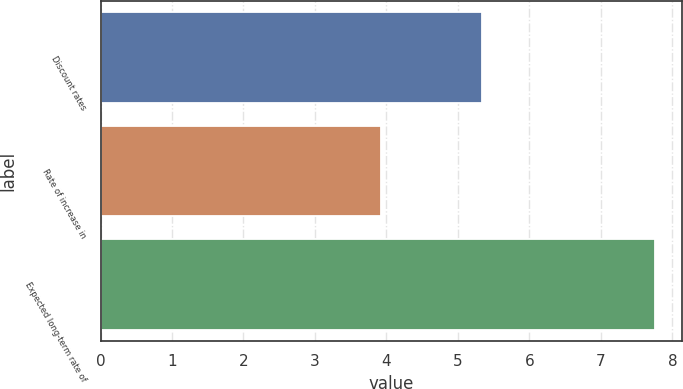<chart> <loc_0><loc_0><loc_500><loc_500><bar_chart><fcel>Discount rates<fcel>Rate of increase in<fcel>Expected long-term rate of<nl><fcel>5.34<fcel>3.93<fcel>7.75<nl></chart> 